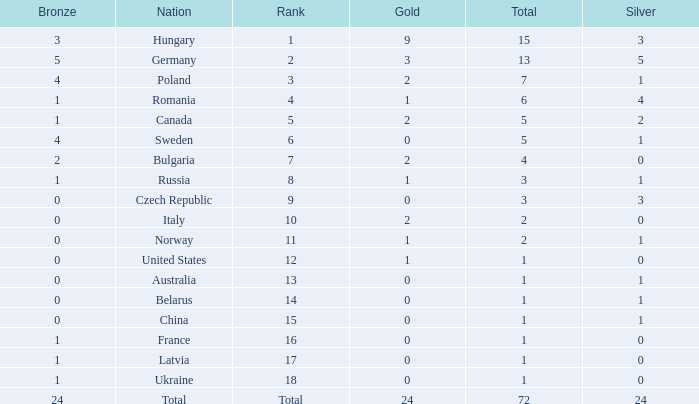What average silver has belarus as the nation, with a total less than 1? None. 